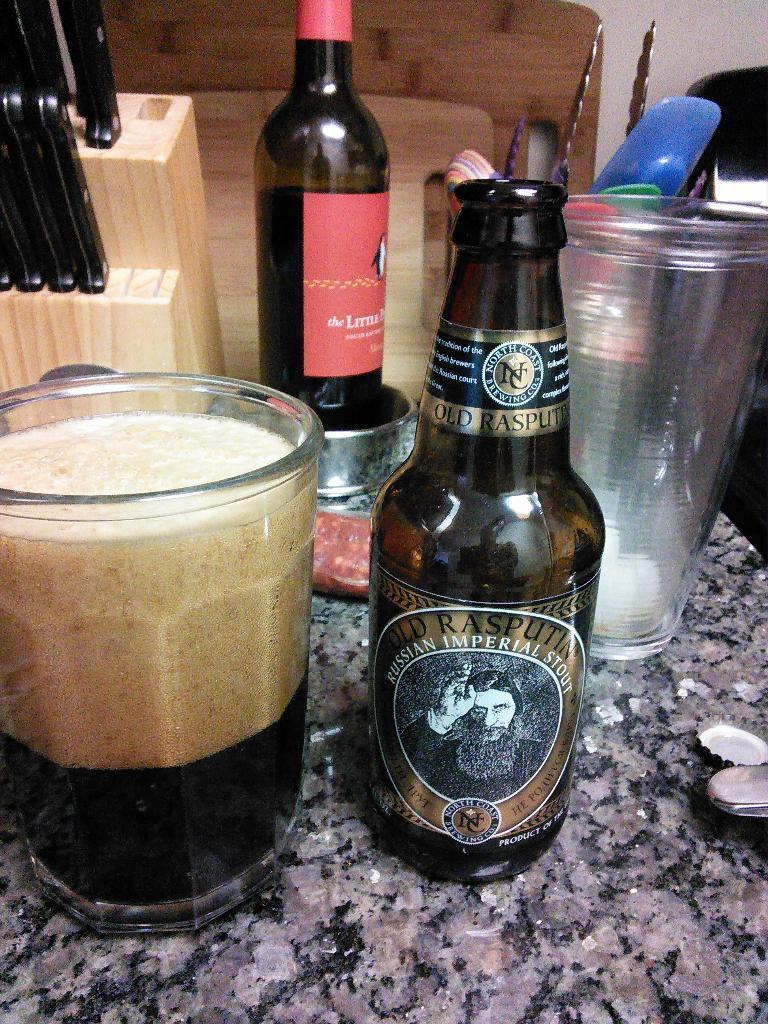Provide a one-sentence caption for the provided image. A messy kitchen counter with a Russian Imperial Stout beer bottle. 